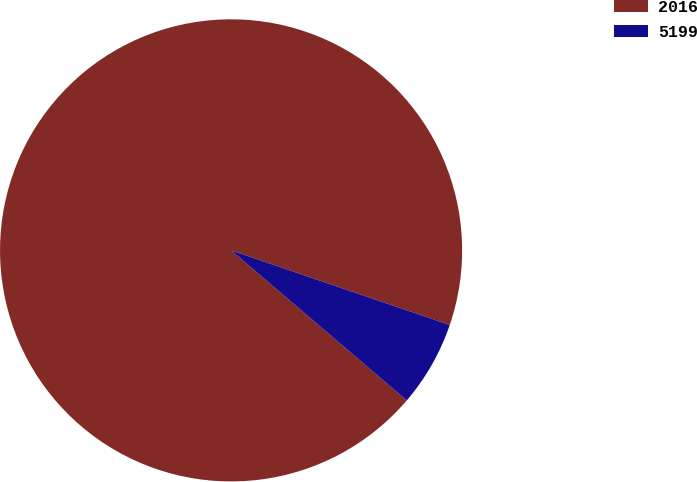Convert chart. <chart><loc_0><loc_0><loc_500><loc_500><pie_chart><fcel>2016<fcel>5199<nl><fcel>93.98%<fcel>6.02%<nl></chart> 